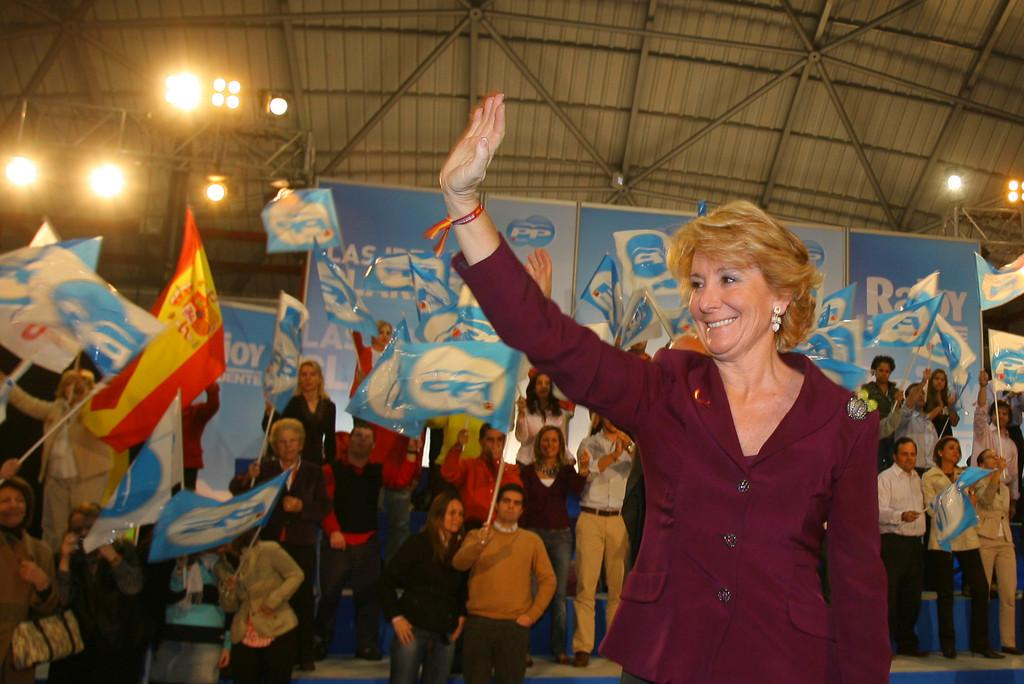Who is present on the right side of the image? There is a lady standing on the right side of the image. What are the people in the background doing? In the background, there are people holding flags in their hands. What objects can be seen in the image besides the lady and the people with flags? Boards are visible in the image. What can be seen at the top of the image? There are lights at the top of the image. What type of loaf is being served at the country event in the image? There is no loaf or country event present in the image. What kind of trip are the people taking in the image? There is no trip or indication of travel in the image. 